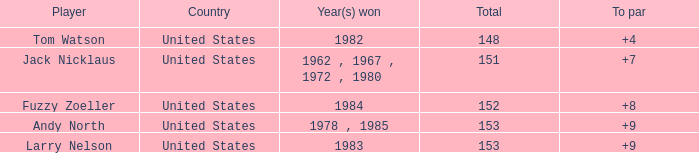What is the Total of the Player with a To par of 4? 1.0. 